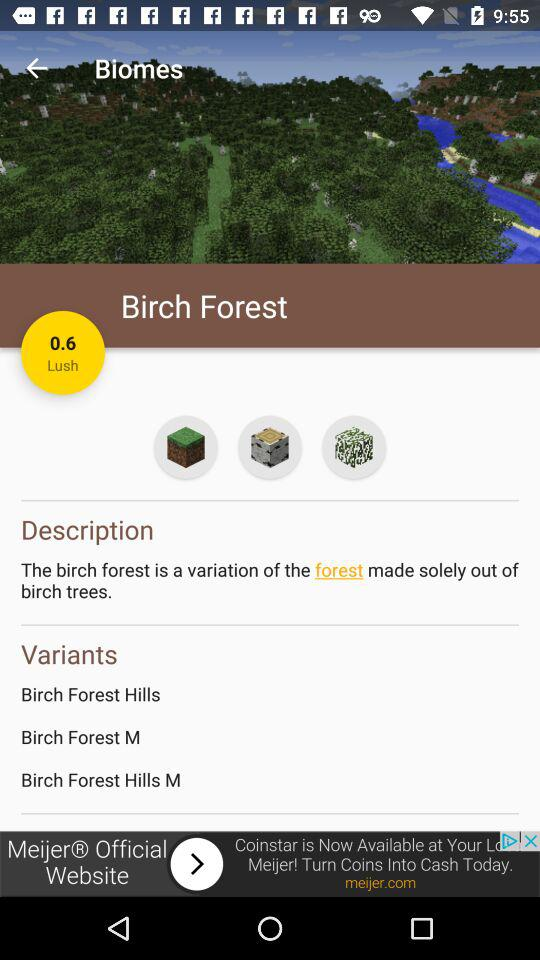How many variants of Birch Forest are there?
Answer the question using a single word or phrase. 3 